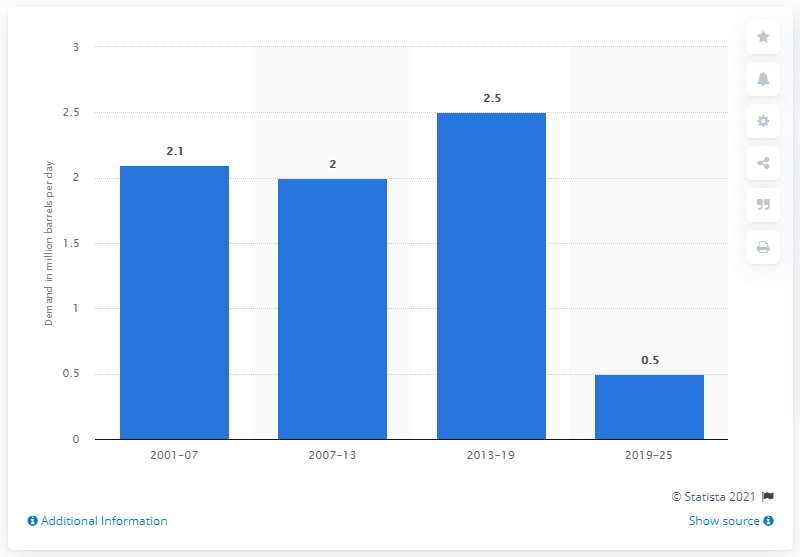Mention a couple of crucial points in this snapshot. The global gasoline demand is expected to be between 0.5 and 0.65 billion liters between 2019 and 2025. 